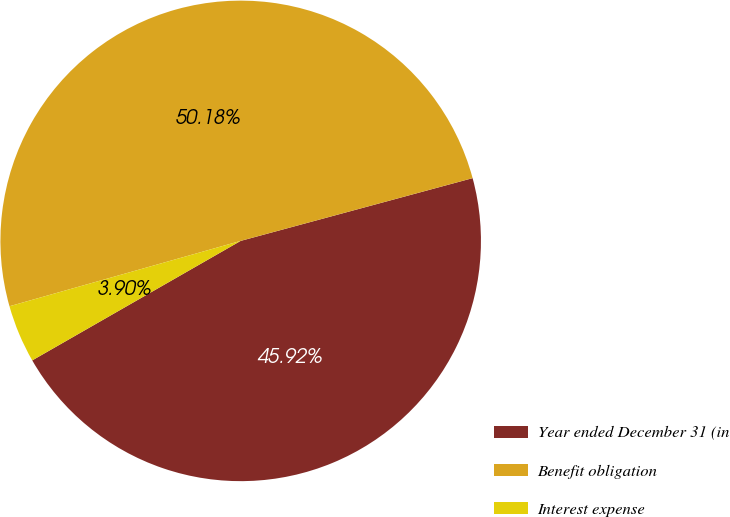Convert chart to OTSL. <chart><loc_0><loc_0><loc_500><loc_500><pie_chart><fcel>Year ended December 31 (in<fcel>Benefit obligation<fcel>Interest expense<nl><fcel>45.92%<fcel>50.18%<fcel>3.9%<nl></chart> 